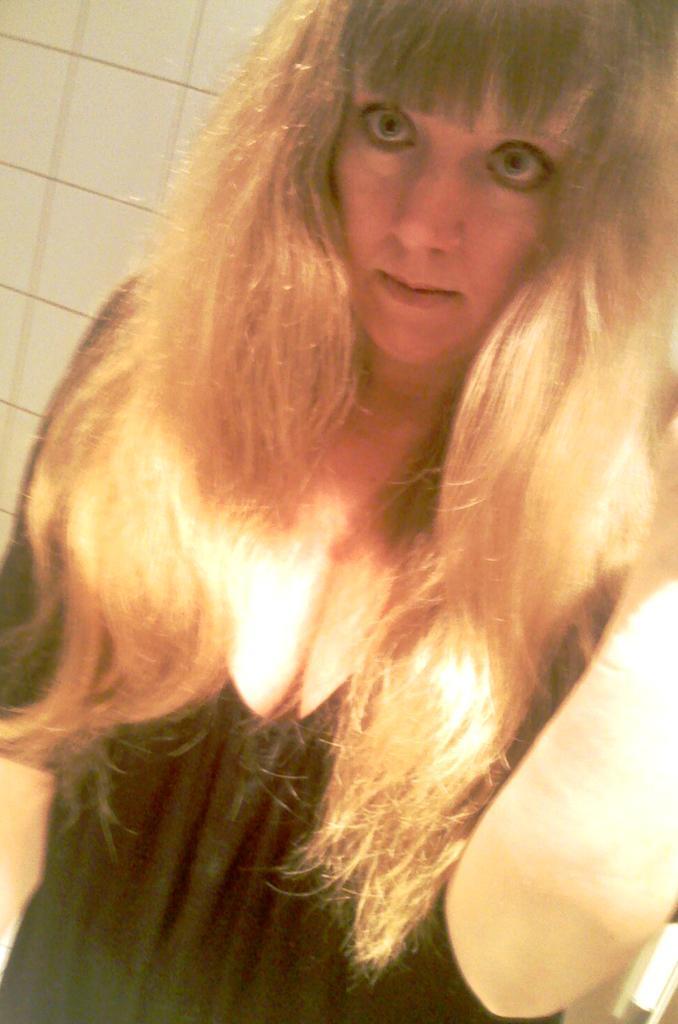Please provide a concise description of this image. In this image, we can see a woman in black dress is seeing. Background there is a wall. 